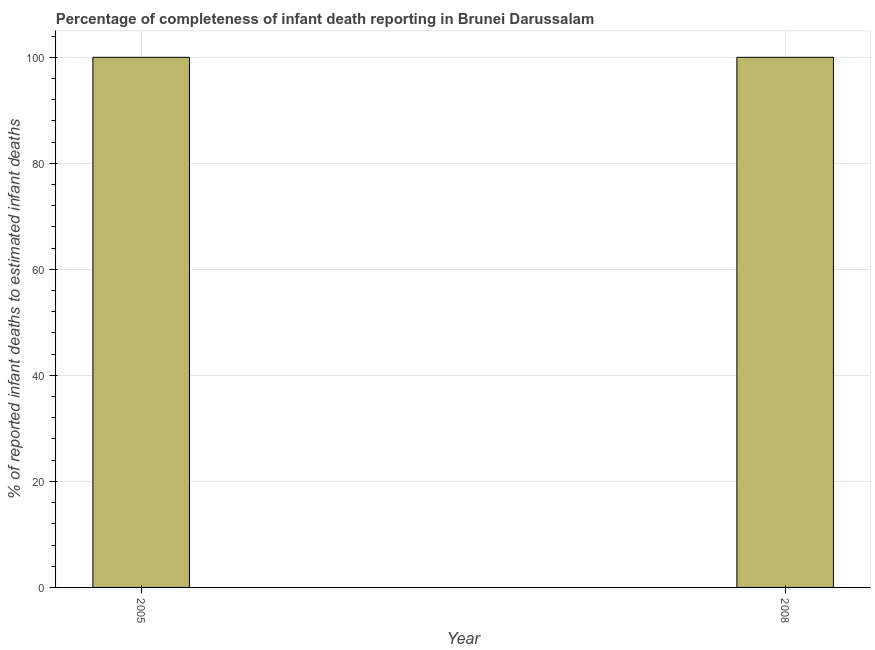Does the graph contain grids?
Provide a short and direct response. Yes. What is the title of the graph?
Provide a short and direct response. Percentage of completeness of infant death reporting in Brunei Darussalam. What is the label or title of the X-axis?
Provide a short and direct response. Year. What is the label or title of the Y-axis?
Keep it short and to the point. % of reported infant deaths to estimated infant deaths. What is the completeness of infant death reporting in 2008?
Give a very brief answer. 100. Across all years, what is the maximum completeness of infant death reporting?
Your answer should be compact. 100. In which year was the completeness of infant death reporting maximum?
Your answer should be compact. 2005. In which year was the completeness of infant death reporting minimum?
Provide a succinct answer. 2005. What is the sum of the completeness of infant death reporting?
Your response must be concise. 200. What is the average completeness of infant death reporting per year?
Offer a terse response. 100. Do a majority of the years between 2008 and 2005 (inclusive) have completeness of infant death reporting greater than 24 %?
Provide a short and direct response. No. Is the completeness of infant death reporting in 2005 less than that in 2008?
Ensure brevity in your answer.  No. In how many years, is the completeness of infant death reporting greater than the average completeness of infant death reporting taken over all years?
Keep it short and to the point. 0. How many years are there in the graph?
Your answer should be compact. 2. Are the values on the major ticks of Y-axis written in scientific E-notation?
Ensure brevity in your answer.  No. What is the % of reported infant deaths to estimated infant deaths in 2008?
Keep it short and to the point. 100. What is the difference between the % of reported infant deaths to estimated infant deaths in 2005 and 2008?
Keep it short and to the point. 0. 